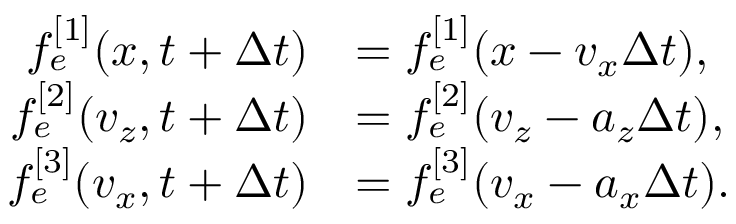Convert formula to latex. <formula><loc_0><loc_0><loc_500><loc_500>\begin{array} { r l } { f _ { e } ^ { [ 1 ] } ( x , t + \Delta t ) } & { = f _ { e } ^ { [ 1 ] } ( x - v _ { x } \Delta t ) , } \\ { f _ { e } ^ { [ 2 ] } ( v _ { z } , t + \Delta t ) } & { = f _ { e } ^ { [ 2 ] } ( v _ { z } - a _ { z } \Delta t ) , } \\ { f _ { e } ^ { [ 3 ] } ( v _ { x } , t + \Delta t ) } & { = f _ { e } ^ { [ 3 ] } ( v _ { x } - a _ { x } \Delta t ) . } \end{array}</formula> 